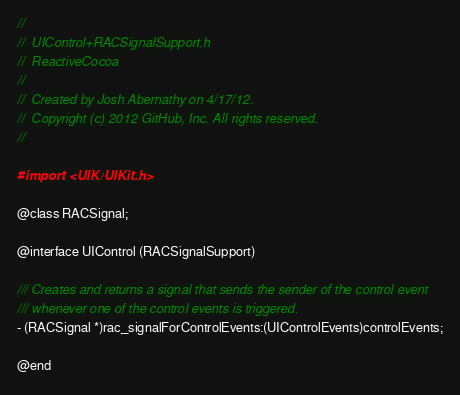Convert code to text. <code><loc_0><loc_0><loc_500><loc_500><_C_>//
//  UIControl+RACSignalSupport.h
//  ReactiveCocoa
//
//  Created by Josh Abernathy on 4/17/12.
//  Copyright (c) 2012 GitHub, Inc. All rights reserved.
//

#import <UIKit/UIKit.h>

@class RACSignal;

@interface UIControl (RACSignalSupport)

/// Creates and returns a signal that sends the sender of the control event
/// whenever one of the control events is triggered.
- (RACSignal *)rac_signalForControlEvents:(UIControlEvents)controlEvents;

@end
</code> 